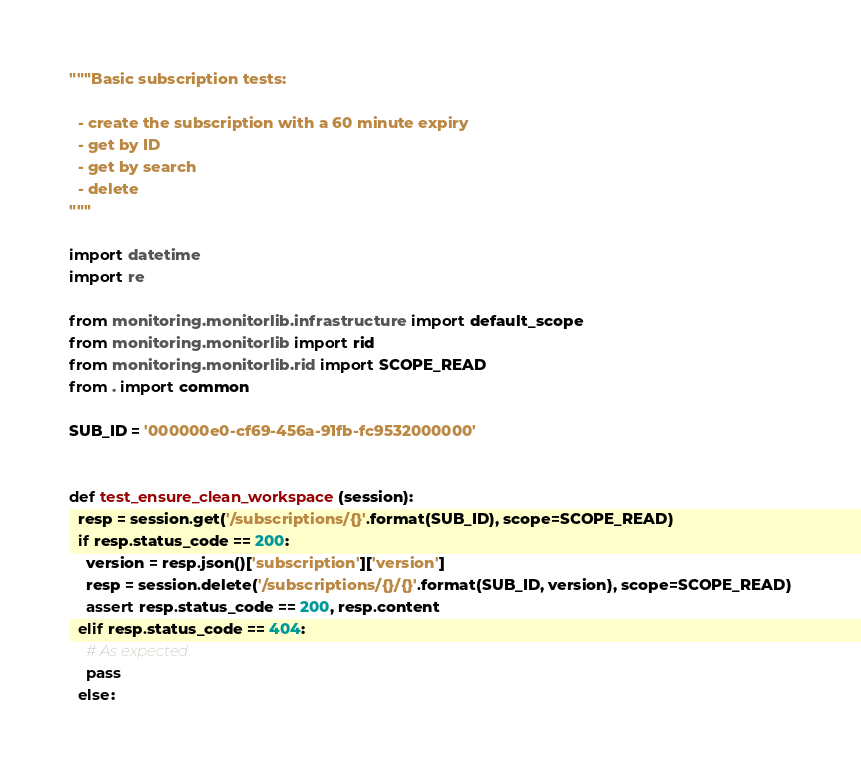<code> <loc_0><loc_0><loc_500><loc_500><_Python_>"""Basic subscription tests:

  - create the subscription with a 60 minute expiry
  - get by ID
  - get by search
  - delete
"""

import datetime
import re

from monitoring.monitorlib.infrastructure import default_scope
from monitoring.monitorlib import rid
from monitoring.monitorlib.rid import SCOPE_READ
from . import common

SUB_ID = '000000e0-cf69-456a-91fb-fc9532000000'


def test_ensure_clean_workspace(session):
  resp = session.get('/subscriptions/{}'.format(SUB_ID), scope=SCOPE_READ)
  if resp.status_code == 200:
    version = resp.json()['subscription']['version']
    resp = session.delete('/subscriptions/{}/{}'.format(SUB_ID, version), scope=SCOPE_READ)
    assert resp.status_code == 200, resp.content
  elif resp.status_code == 404:
    # As expected.
    pass
  else:</code> 